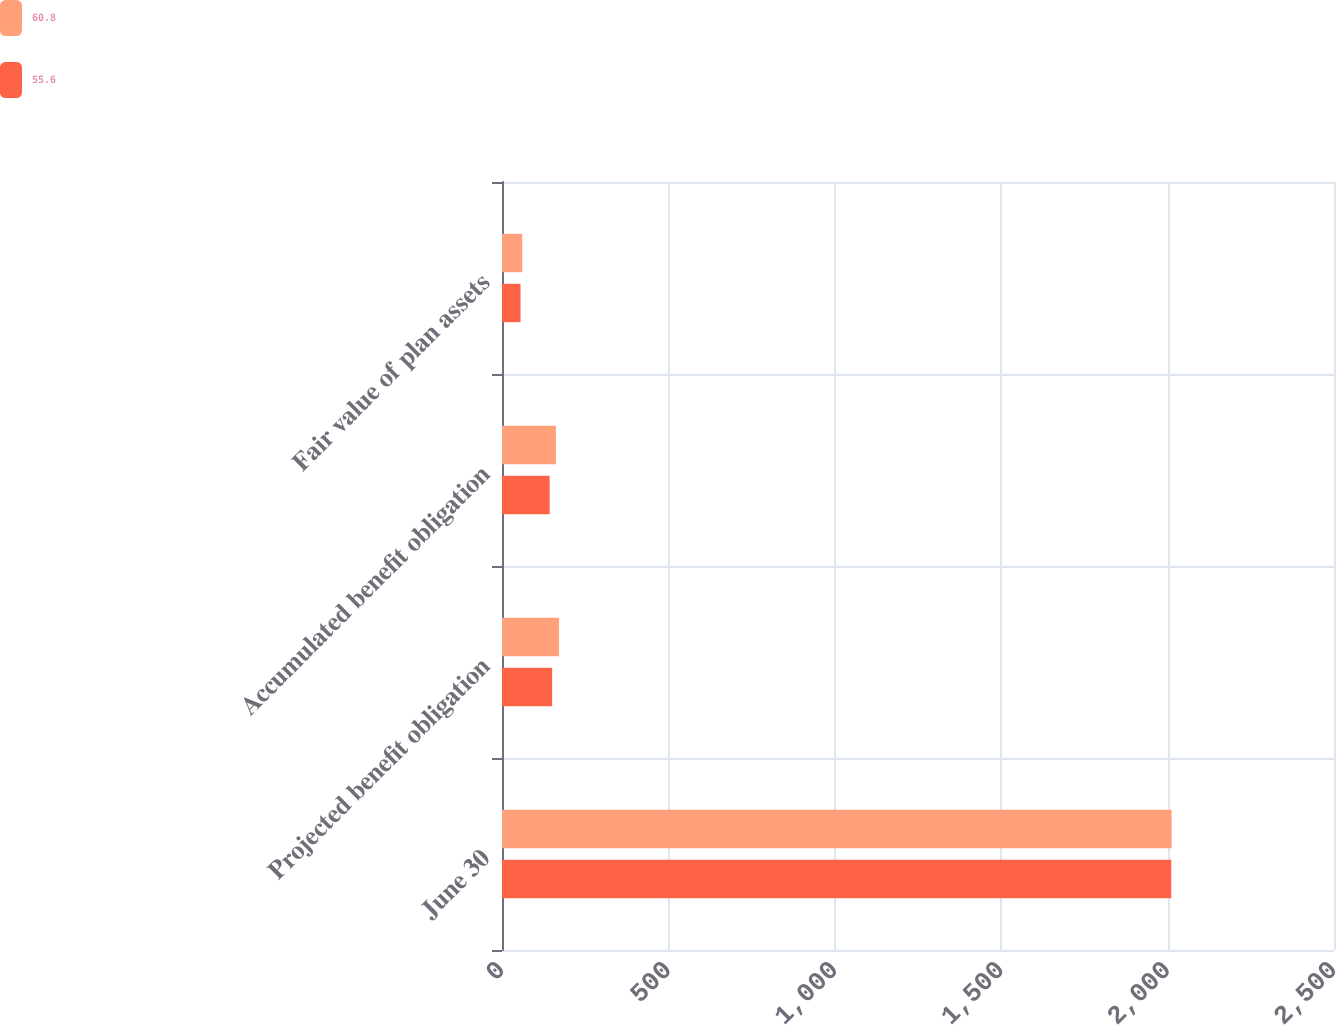<chart> <loc_0><loc_0><loc_500><loc_500><stacked_bar_chart><ecel><fcel>June 30<fcel>Projected benefit obligation<fcel>Accumulated benefit obligation<fcel>Fair value of plan assets<nl><fcel>60.8<fcel>2012<fcel>171.5<fcel>161.8<fcel>60.8<nl><fcel>55.6<fcel>2011<fcel>150.7<fcel>143.2<fcel>55.6<nl></chart> 